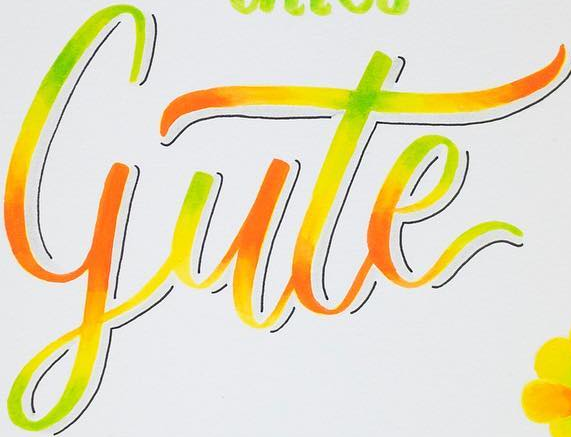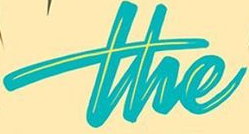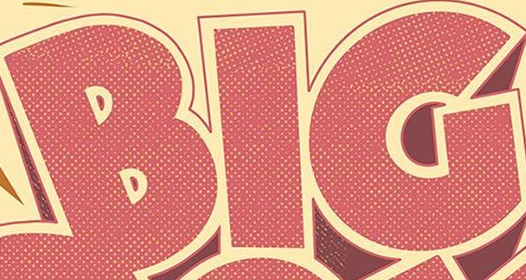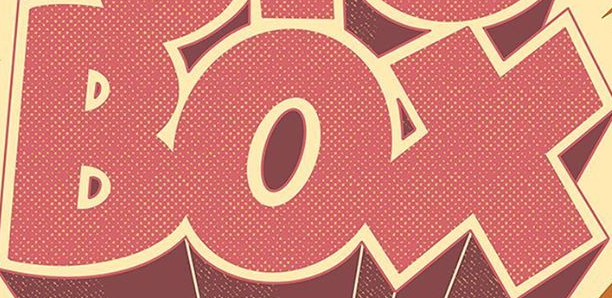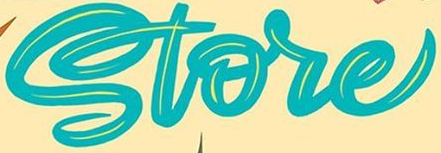Identify the words shown in these images in order, separated by a semicolon. gute; the; BIG; BOX; Store 